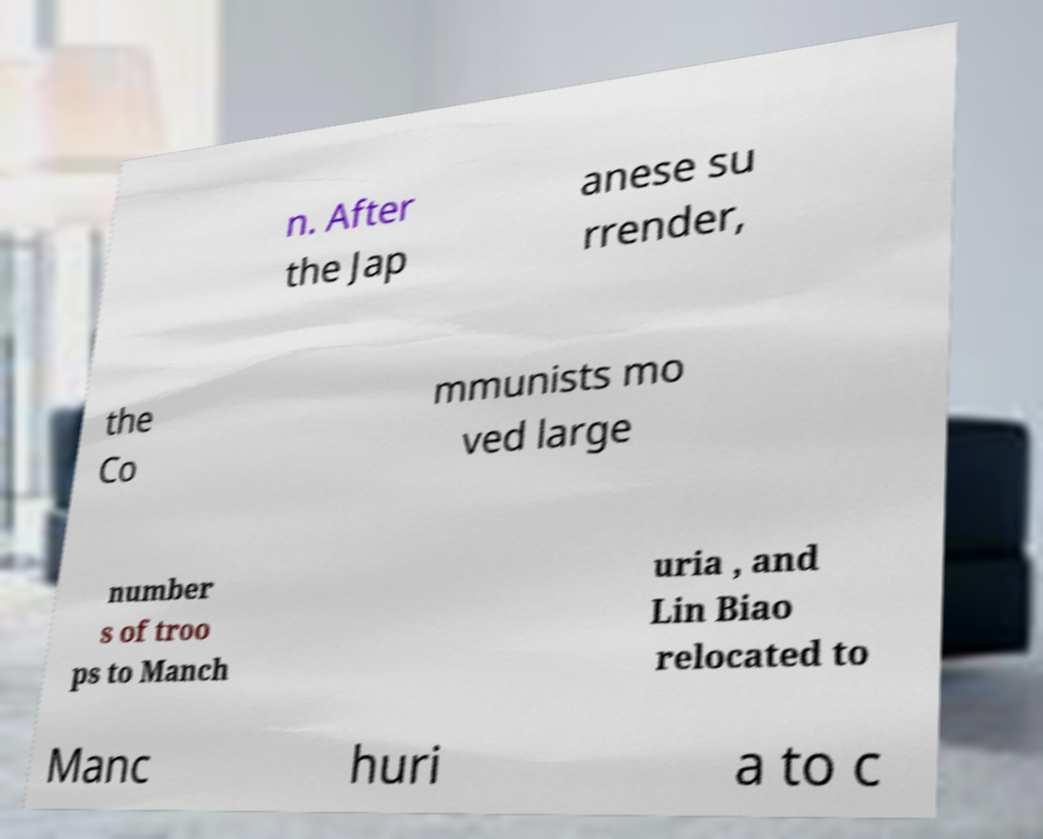For documentation purposes, I need the text within this image transcribed. Could you provide that? n. After the Jap anese su rrender, the Co mmunists mo ved large number s of troo ps to Manch uria , and Lin Biao relocated to Manc huri a to c 